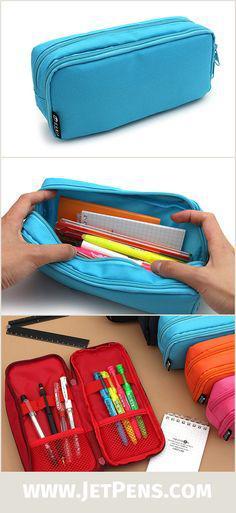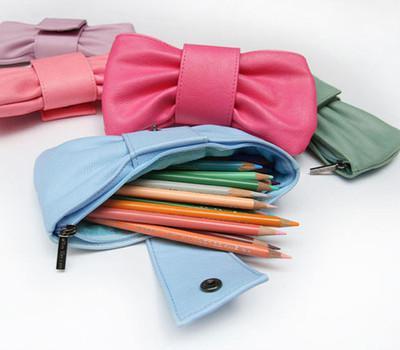The first image is the image on the left, the second image is the image on the right. Assess this claim about the two images: "Two light blue pencil bags are unzipped and showing the inside.". Correct or not? Answer yes or no. Yes. The first image is the image on the left, the second image is the image on the right. Examine the images to the left and right. Is the description "there is a mesh pocket on the front of a pencil case" accurate? Answer yes or no. No. 